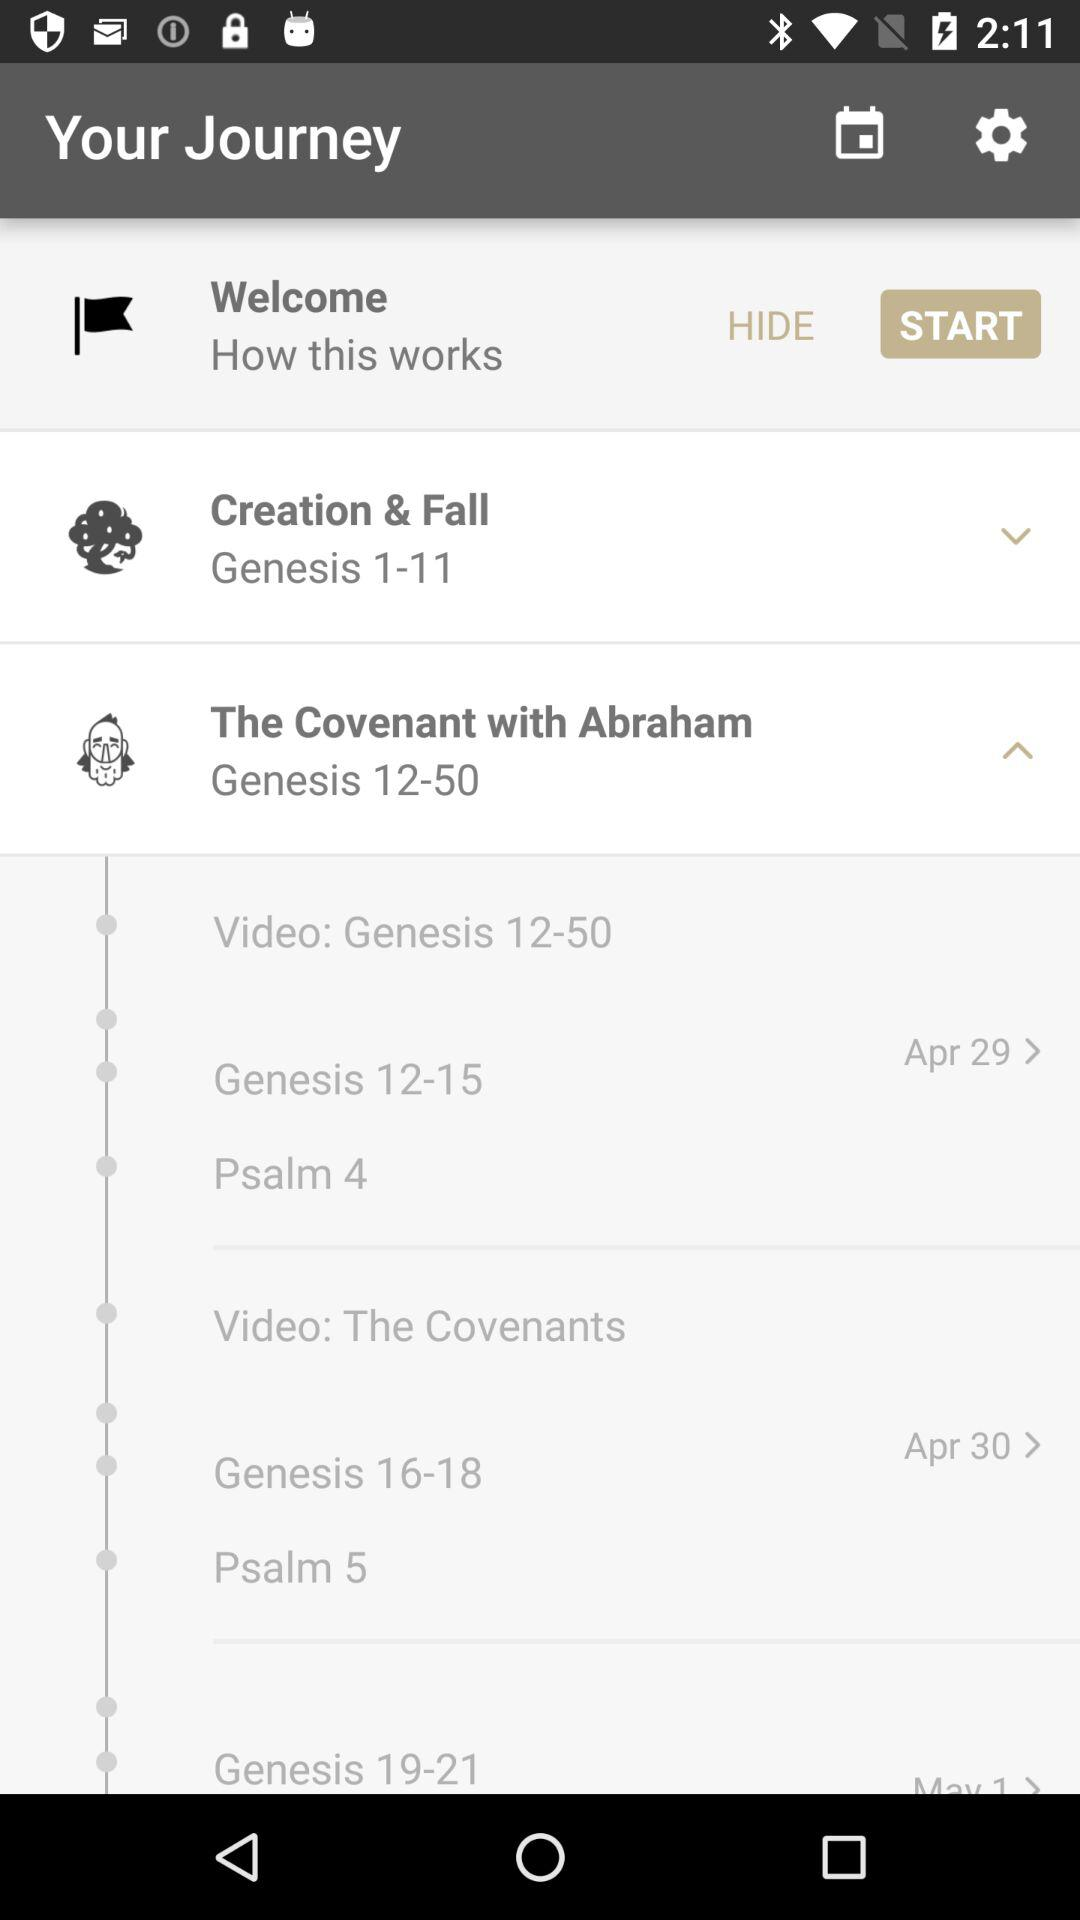What is the scheduled date for "The Covenants"? The scheduled date for "The Covenants" is April 30. 